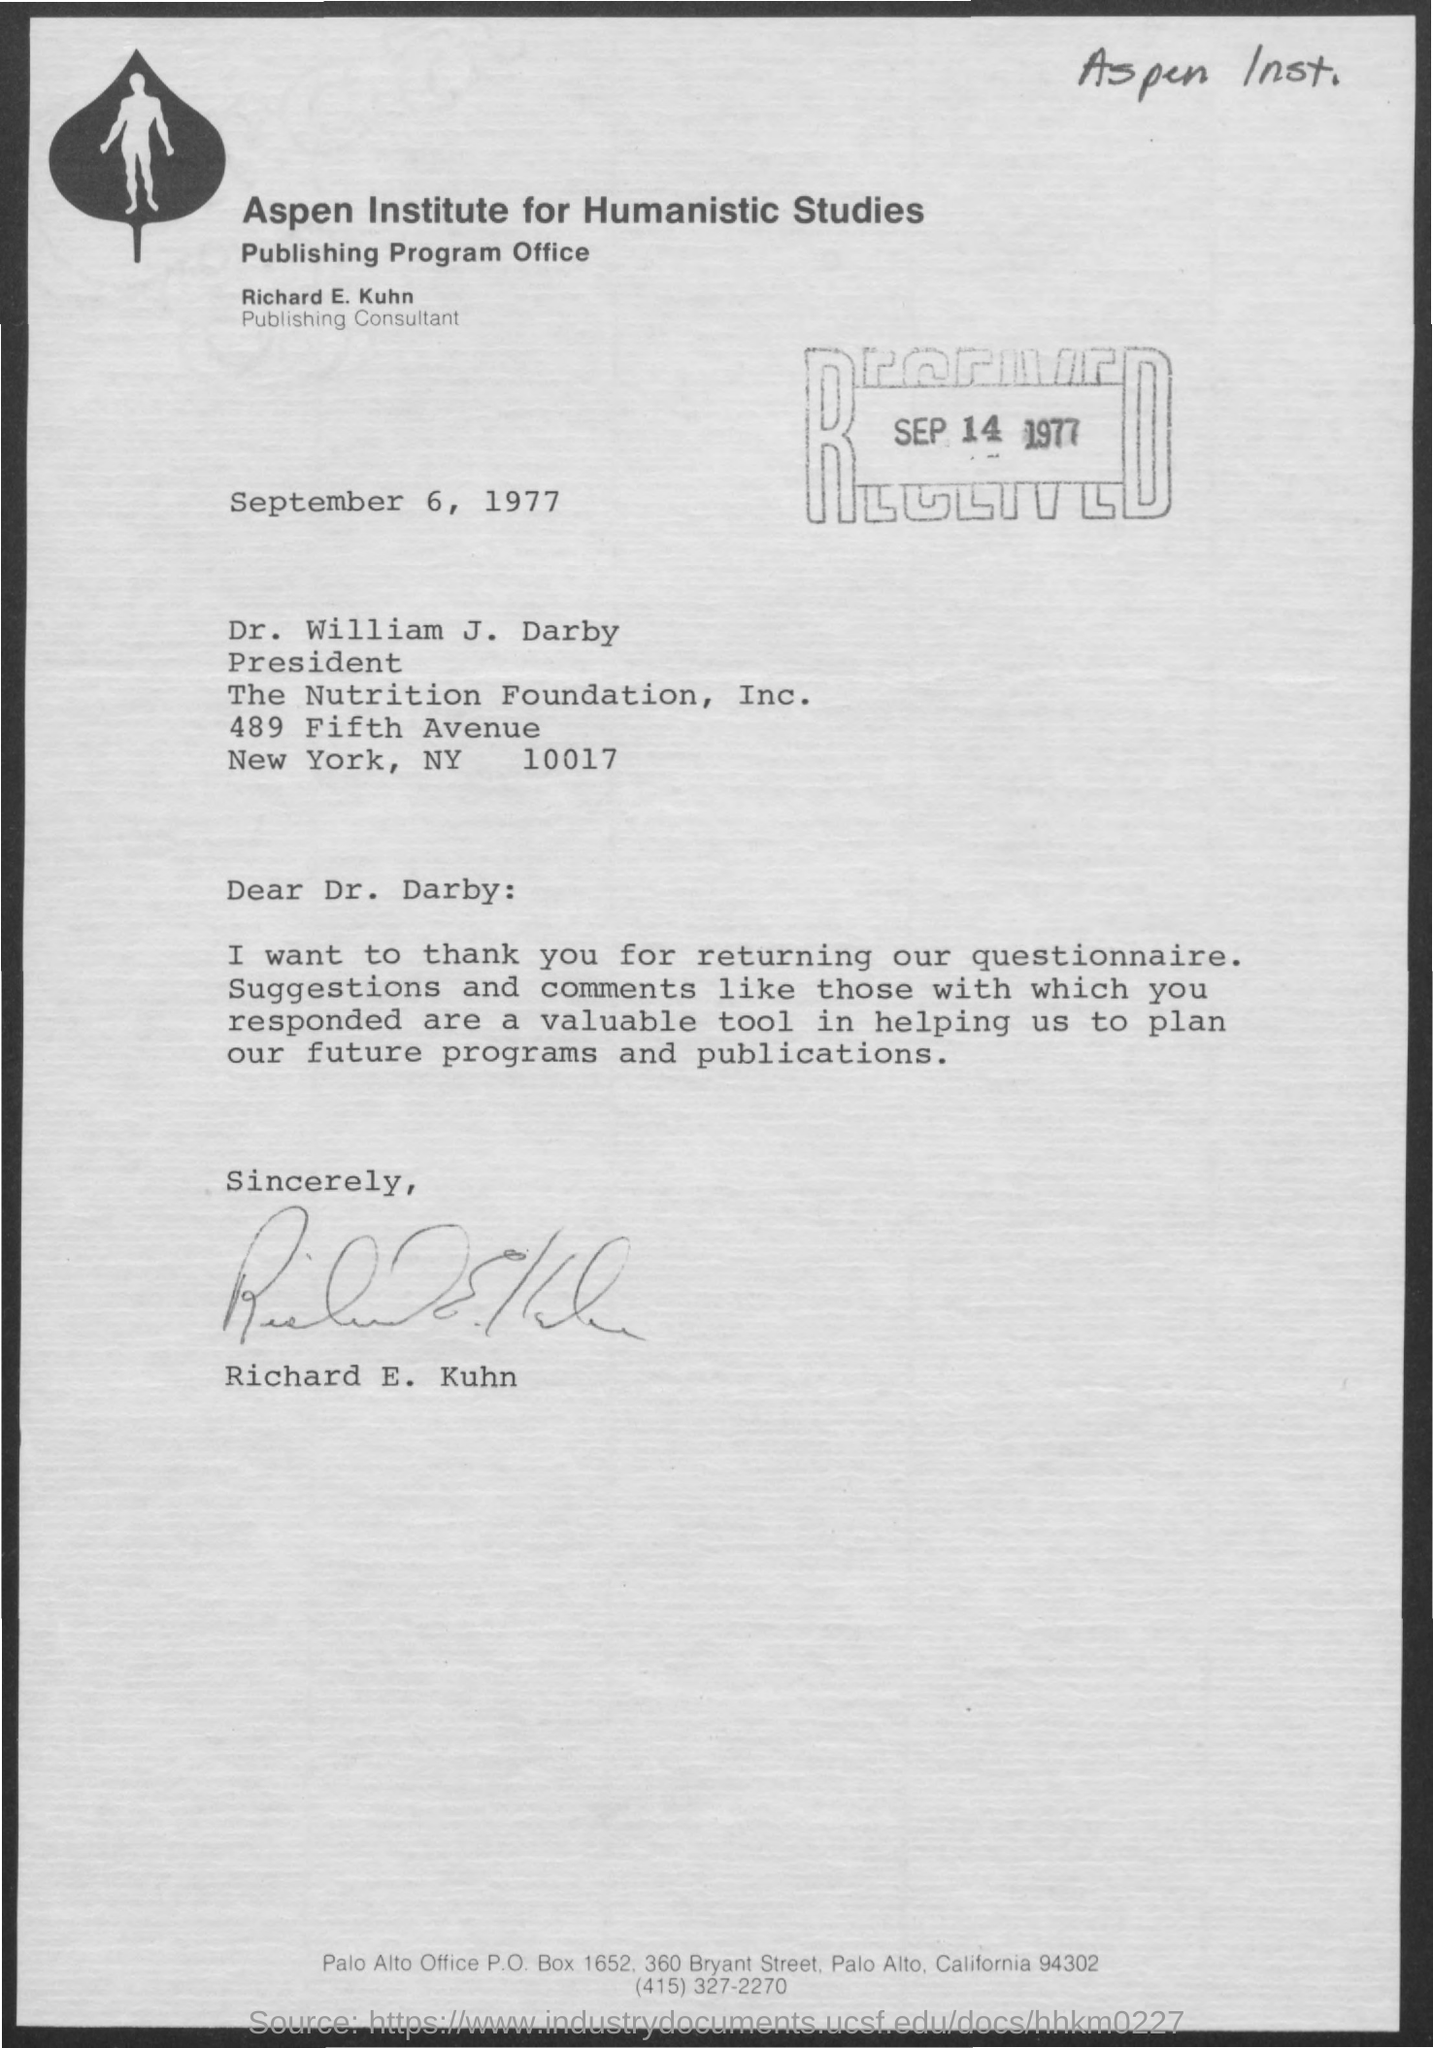Point out several critical features in this image. The date of the letter is September 6, 1977. Richard E. Kuhn holds the designation of a publishing consultant. 